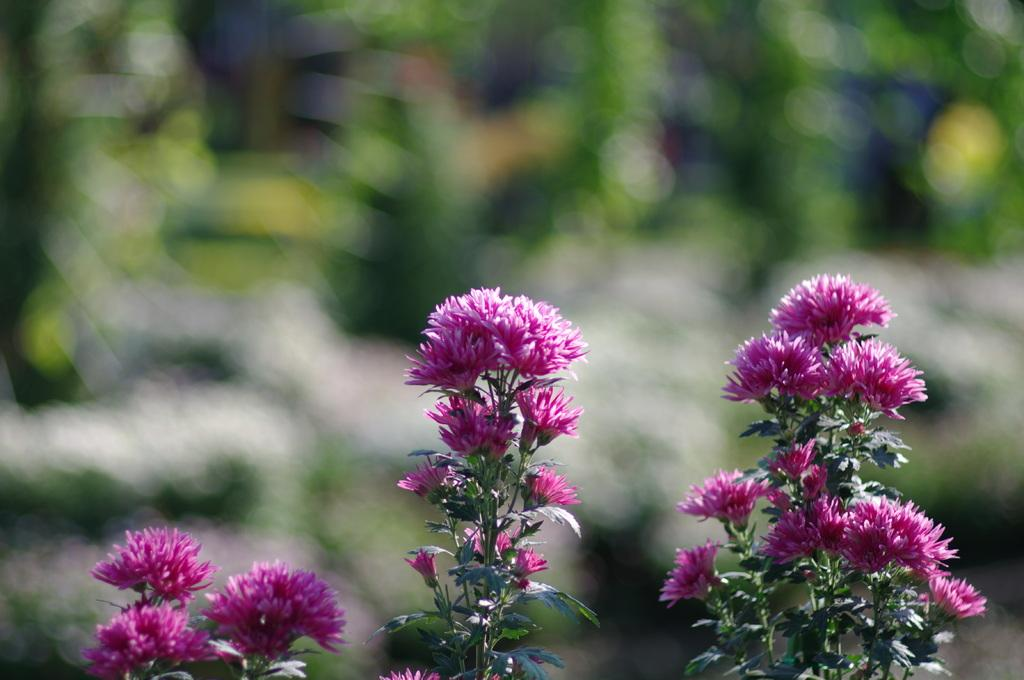What type of plants can be seen in the image? There are flowers and leaves in the image. What is the appearance of the background in the image? The background of the image is blurred. What can be observed in the background of the image? There is greenery in the background of the image. What type of dinner is being served on the canvas in the image? There is no canvas or dinner present in the image; it features flowers and leaves with a blurred background. 